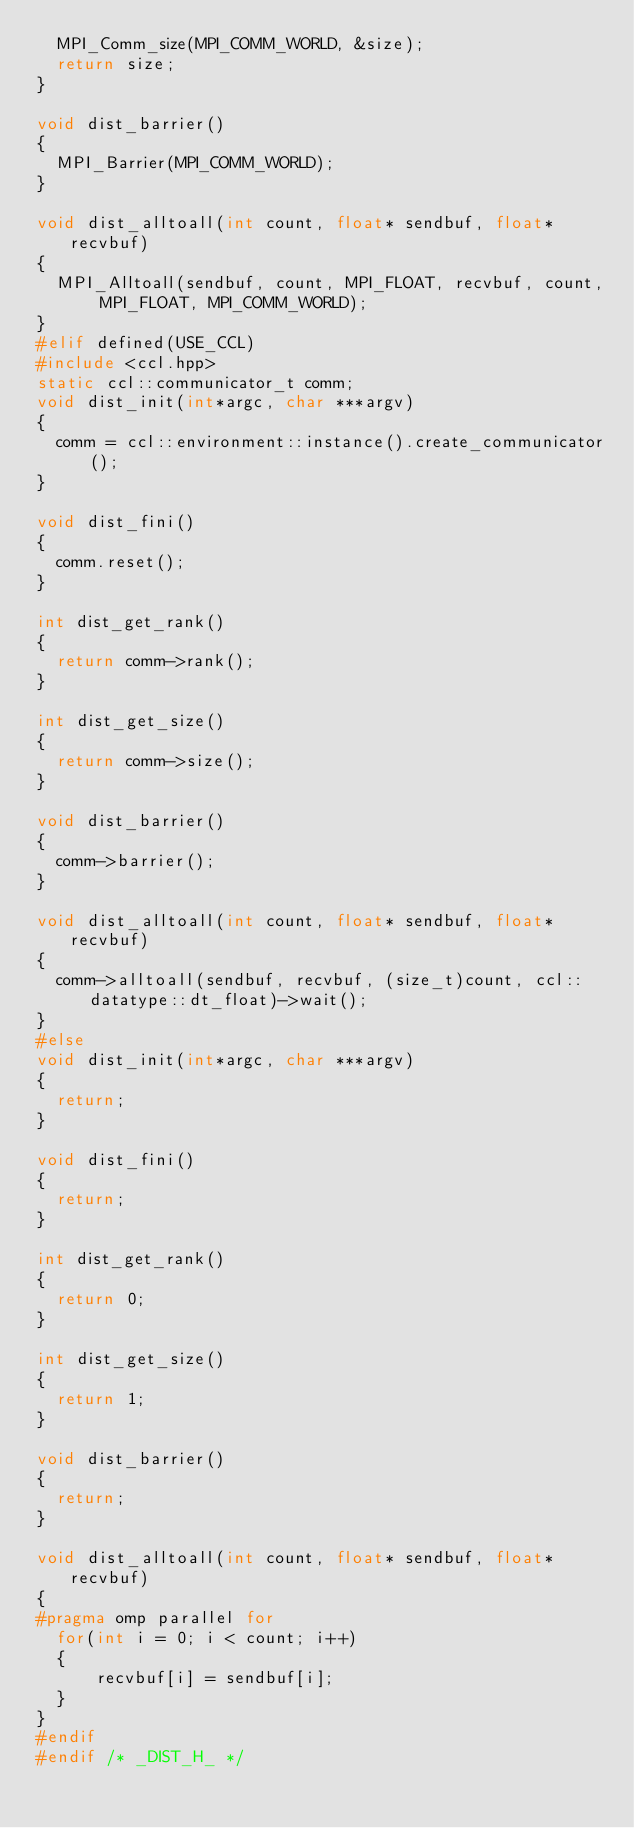<code> <loc_0><loc_0><loc_500><loc_500><_C_>  MPI_Comm_size(MPI_COMM_WORLD, &size);
  return size;
}

void dist_barrier()
{
  MPI_Barrier(MPI_COMM_WORLD);
}

void dist_alltoall(int count, float* sendbuf, float*recvbuf)
{
  MPI_Alltoall(sendbuf, count, MPI_FLOAT, recvbuf, count, MPI_FLOAT, MPI_COMM_WORLD);
}
#elif defined(USE_CCL)
#include <ccl.hpp>
static ccl::communicator_t comm;
void dist_init(int*argc, char ***argv)
{
  comm = ccl::environment::instance().create_communicator();
}

void dist_fini()
{
  comm.reset();
}

int dist_get_rank()
{
  return comm->rank();
}

int dist_get_size()
{
  return comm->size();
}

void dist_barrier()
{
  comm->barrier();
}

void dist_alltoall(int count, float* sendbuf, float*recvbuf)
{
  comm->alltoall(sendbuf, recvbuf, (size_t)count, ccl::datatype::dt_float)->wait();
}
#else
void dist_init(int*argc, char ***argv)
{
  return;
}

void dist_fini()
{
  return;
}

int dist_get_rank()
{
  return 0;
}

int dist_get_size()
{
  return 1;
}

void dist_barrier()
{
  return;
}

void dist_alltoall(int count, float* sendbuf, float*recvbuf)
{
#pragma omp parallel for
  for(int i = 0; i < count; i++)
  {
      recvbuf[i] = sendbuf[i];
  }
}
#endif
#endif /* _DIST_H_ */
</code> 